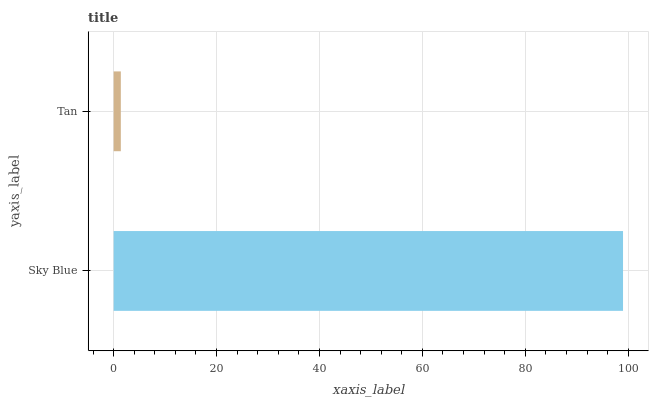Is Tan the minimum?
Answer yes or no. Yes. Is Sky Blue the maximum?
Answer yes or no. Yes. Is Tan the maximum?
Answer yes or no. No. Is Sky Blue greater than Tan?
Answer yes or no. Yes. Is Tan less than Sky Blue?
Answer yes or no. Yes. Is Tan greater than Sky Blue?
Answer yes or no. No. Is Sky Blue less than Tan?
Answer yes or no. No. Is Sky Blue the high median?
Answer yes or no. Yes. Is Tan the low median?
Answer yes or no. Yes. Is Tan the high median?
Answer yes or no. No. Is Sky Blue the low median?
Answer yes or no. No. 